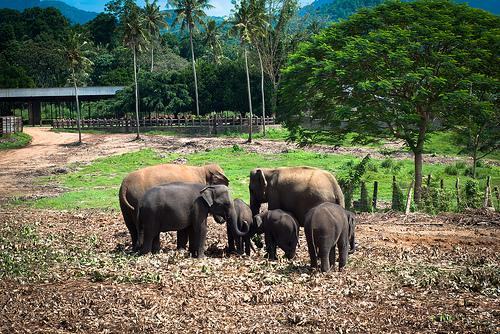Describe the main elements of the image using a humorous tone. Oh look! There's an elephant fiesta going on in this dry grassland, with fences that have seen better days, and the trees desperately trying to get in on the action. Describe the atmosphere and surroundings in the image in three adjectives. Serene, pastoral, and enclosed. Using alliteration, create a phrase that describes the image. Elephants elegantly embrace and emanate enthusiasm in their enclosed, earthy, and enchanting environment. Write a haiku that captures the essence of the scene in the image. Peaceful family. Narrate a story happening in the scene displayed in the image. In the quiet pasture, an elephant family reunion takes place, surrounded by green grass and protective fences. Elephant elders share tales of wisdom while the young ones playfully curl their trunks. Describe the image from the perspective of an animal living in the scene. I'm an elephant in this warm, grassy pasture, and I'm hanging out with my family, playing with my siblings, and enjoying the company of the trees and fences around us. Write a news headline that summarizes the main events in the image. Family of Elephants Enjoy a Peaceful Gathering in a Pastoral Landscape, Enclosed by Fences and Shaded by Trees. Give a poetic description of the scene captured in the image. Underneath the blue sky lies a family of majestic elephants, basking in the serene glow of their pasture, framed by verdant trees and timeworn fences. Write a single sentence describing the primary focus of the image. A family of elephants, both adult and young, convene in a serene pasture, surrounded by grass, trees, and fences. Provide a brief overview of the key features in the image. The image features a family of gray elephants, including adults and babies, gathered together in a pasture with green and dry grass, wooden and concrete fences, and trees in the background. 